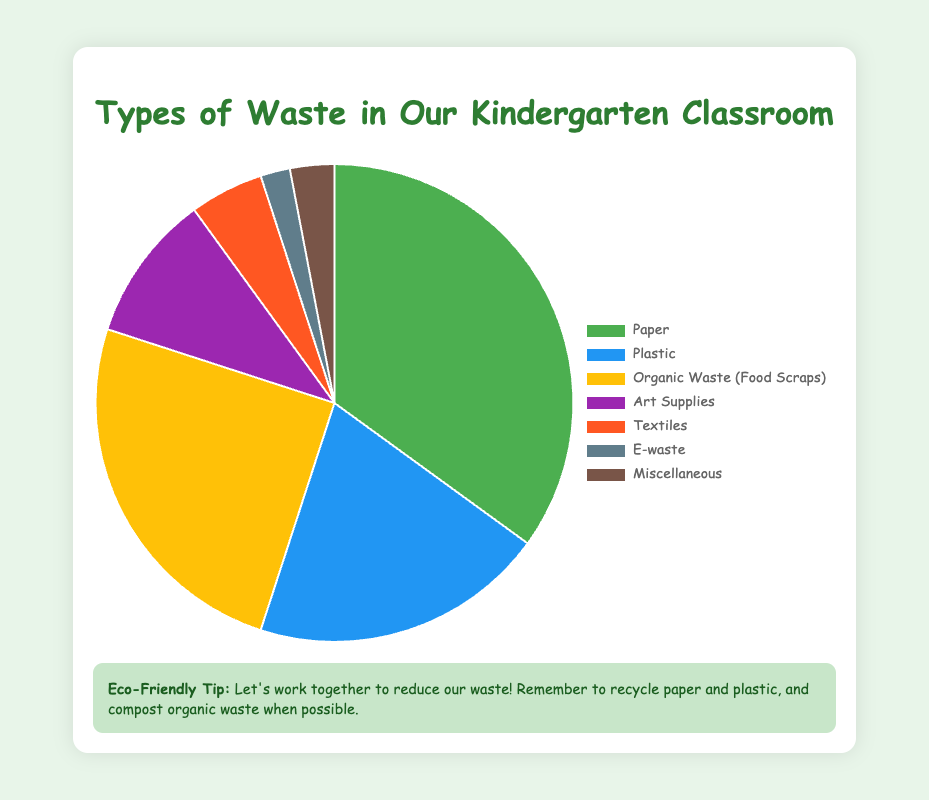Which type of waste constitutes the largest percentage? According to the pie chart, Paper makes up the largest percentage of waste in the kindergarten classroom at 35%.
Answer: Paper Which type of waste constitutes the smallest percentage? The pie chart indicates that E-waste constitutes the smallest percentage of waste at 2%.
Answer: E-waste What is the combined percentage of Paper and Plastic waste? To determine the combined percentage, add the percentage of Paper (35%) to the percentage of Plastic (20%). Thus, the combined percentage is 35% + 20% = 55%.
Answer: 55% How much larger is the percentage of Organic Waste compared to Textiles? To find the difference, subtract the percentage of Textiles (5%) from the percentage of Organic Waste (25%). Therefore, 25% - 5% = 20%.
Answer: 20% Which category of waste is represented by the yellow color in the pie chart? According to the descriptive color scheme, the yellow color in the pie chart corresponds to Organic Waste (Food Scraps).
Answer: Organic Waste (Food Scraps) How does the percentage of Art Supplies waste compare to the percentage of E-waste? The pie chart shows that Art Supplies make up 10% of the waste, while E-waste makes up 2%. Therefore, Art Supplies have a higher percentage compared to E-waste by 10% - 2% = 8%.
Answer: Art Supplies have 8% more waste What is the total percentage for Art Supplies and Miscellaneous categories combined? To determine the total percentage for Art Supplies (10%) and Miscellaneous (3%), add these two values: 10% + 3% = 13%.
Answer: 13% If Textiles and Miscellaneous waste were combined into one category, what percentage would they make up together? Add the percentage of Textiles (5%) and Miscellaneous (3%) to find the combined percentage: 5% + 3% = 8%.
Answer: 8% What percentage of waste is non-recyclable (assuming Art Supplies and E-waste are non-recyclable)? The percentages for Art Supplies and E-waste are 10% and 2% respectively. Adding these together gives 10% + 2% = 12%.
Answer: 12% Compare the total percentage of Organic Waste and Paper to the rest of the categories combined. Which is larger and by how much? The total percentage of Organic Waste (25%) and Paper (35%) is 25% + 35% = 60%. The total percentage for the remaining categories (Plastic, Art Supplies, Textiles, E-waste, Miscellaneous) is 20% + 10% + 5% + 2% + 3% = 40%. Comparing these sums, 60% is larger than 40% by 60% - 40% = 20%.
Answer: Organic Waste and Paper are larger by 20% 